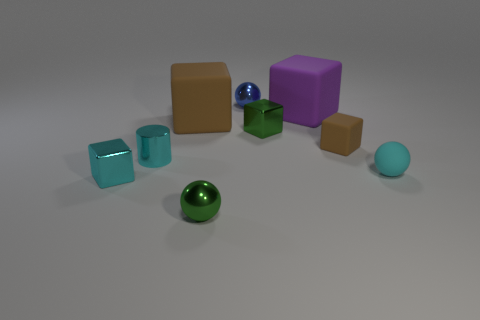There is a metal cube behind the tiny block to the left of the metallic sphere in front of the tiny cyan sphere; what color is it?
Your response must be concise. Green. What is the shape of the small green object that is on the right side of the tiny metal ball in front of the big purple block?
Your response must be concise. Cube. Are there more tiny blue metal balls that are to the right of the small cyan matte sphere than large red balls?
Offer a terse response. No. There is a brown rubber object that is to the left of the small green cube; does it have the same shape as the purple object?
Your answer should be compact. Yes. Is there a large cyan object of the same shape as the big purple object?
Ensure brevity in your answer.  No. How many things are either spheres that are in front of the large purple rubber block or gray metal things?
Your response must be concise. 2. Is the number of green metallic balls greater than the number of tiny cyan objects?
Offer a terse response. No. Is there a purple block that has the same size as the green shiny ball?
Offer a terse response. No. What number of objects are either green metal things that are on the right side of the small blue thing or rubber objects behind the tiny brown block?
Keep it short and to the point. 3. There is a big matte object on the right side of the ball behind the green metallic block; what color is it?
Offer a very short reply. Purple. 